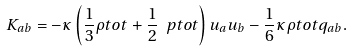<formula> <loc_0><loc_0><loc_500><loc_500>K _ { a b } = - \kappa \left ( \frac { 1 } { 3 } \rho t o t + \frac { 1 } { 2 } \ p t o t \right ) u _ { a } u _ { b } - \frac { 1 } { 6 } \kappa \rho t o t q _ { a b } .</formula> 